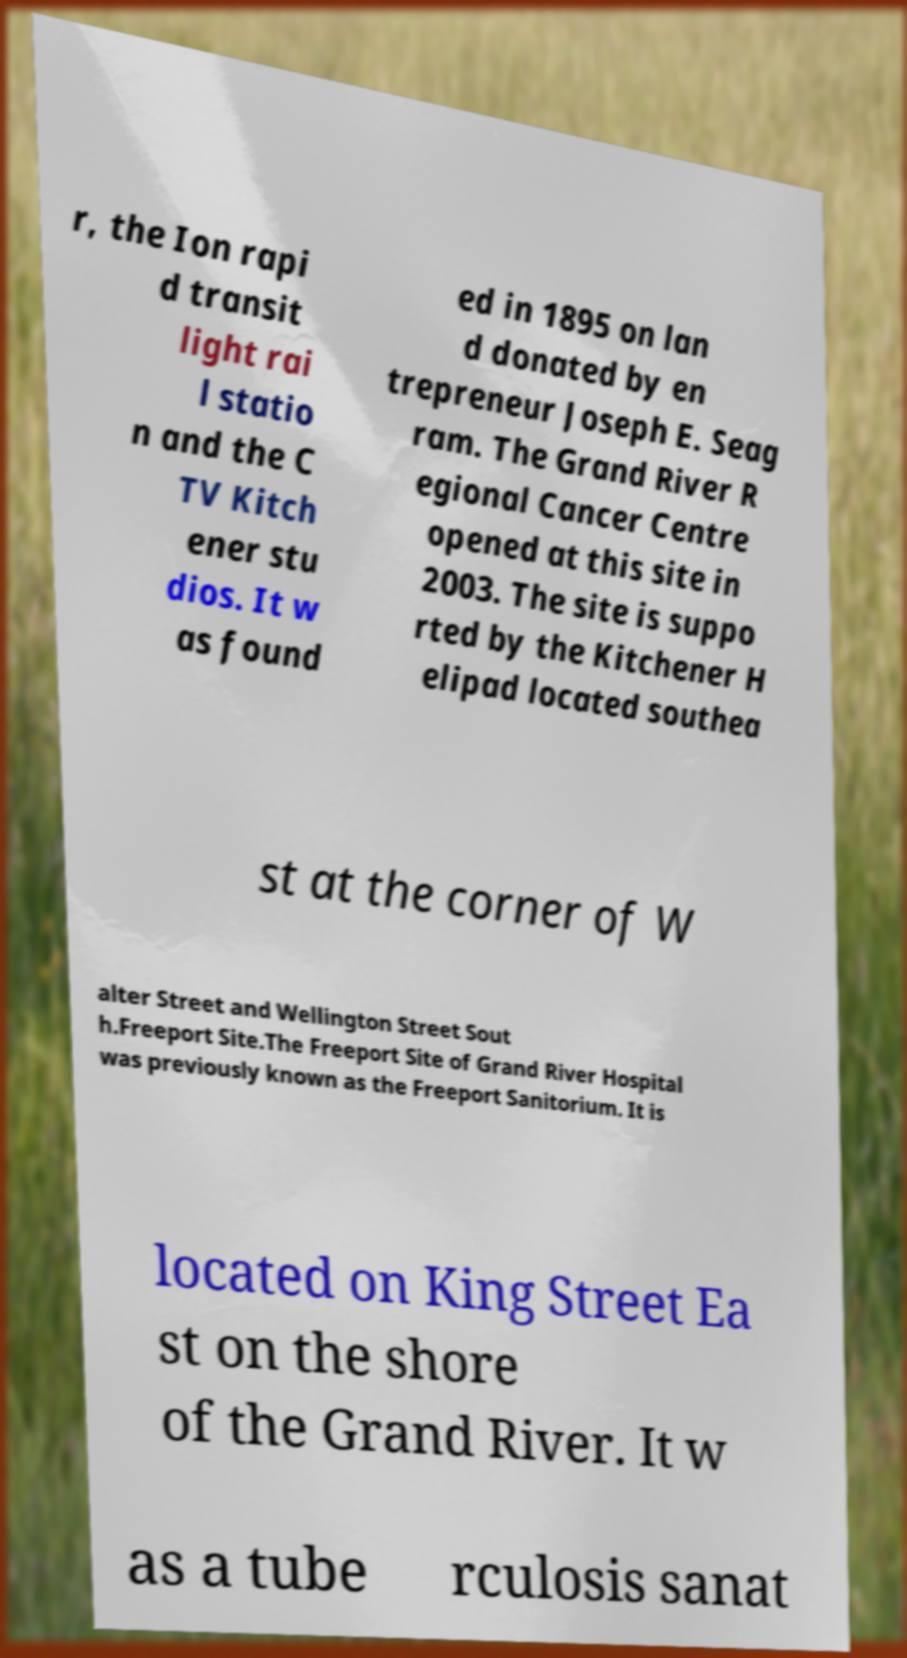I need the written content from this picture converted into text. Can you do that? r, the Ion rapi d transit light rai l statio n and the C TV Kitch ener stu dios. It w as found ed in 1895 on lan d donated by en trepreneur Joseph E. Seag ram. The Grand River R egional Cancer Centre opened at this site in 2003. The site is suppo rted by the Kitchener H elipad located southea st at the corner of W alter Street and Wellington Street Sout h.Freeport Site.The Freeport Site of Grand River Hospital was previously known as the Freeport Sanitorium. It is located on King Street Ea st on the shore of the Grand River. It w as a tube rculosis sanat 